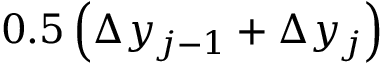Convert formula to latex. <formula><loc_0><loc_0><loc_500><loc_500>0 . 5 \left ( \Delta y _ { j - 1 } + \Delta y _ { j } \right )</formula> 